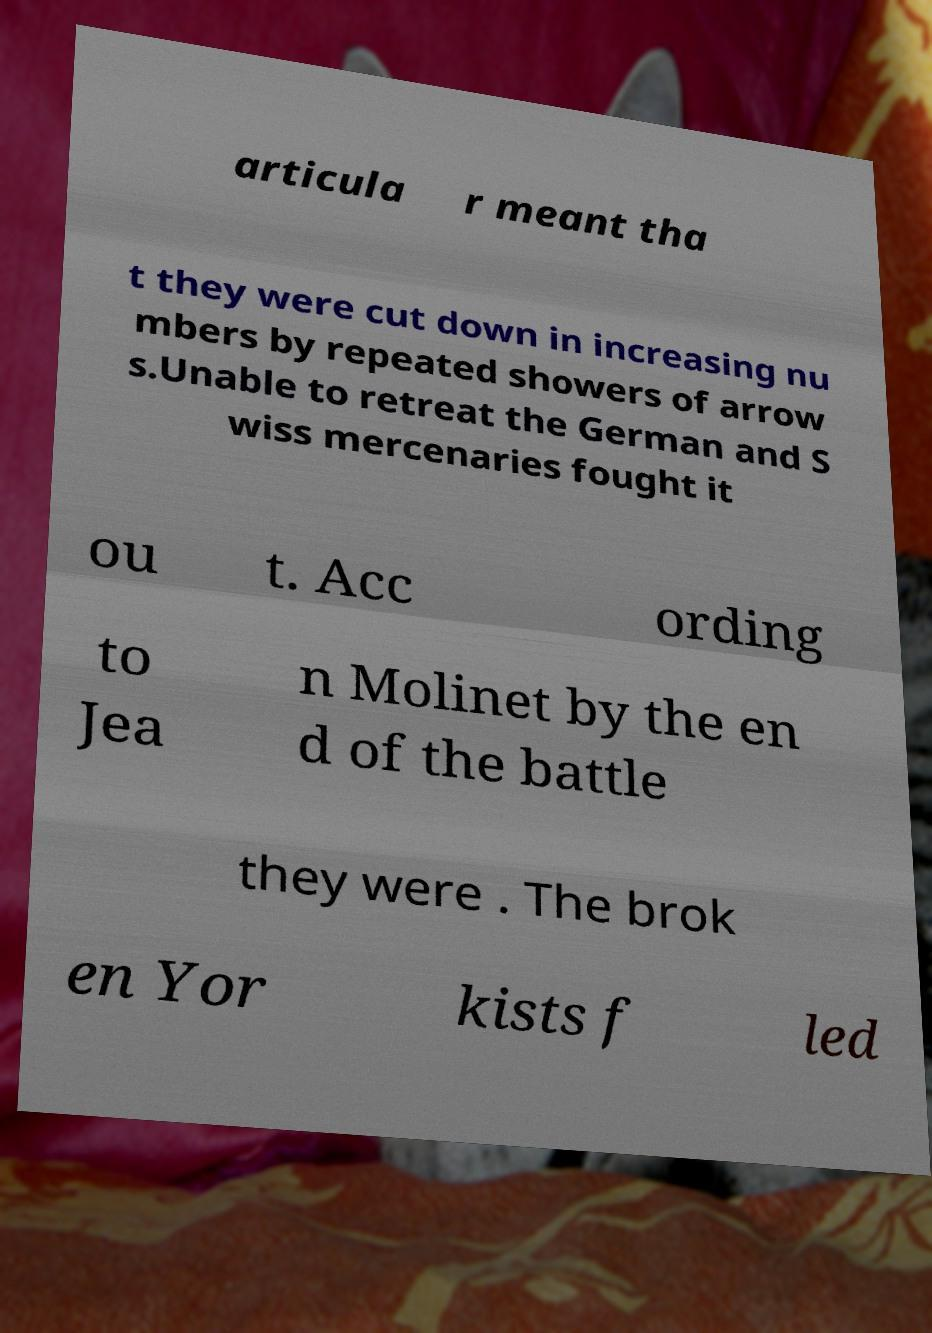For documentation purposes, I need the text within this image transcribed. Could you provide that? articula r meant tha t they were cut down in increasing nu mbers by repeated showers of arrow s.Unable to retreat the German and S wiss mercenaries fought it ou t. Acc ording to Jea n Molinet by the en d of the battle they were . The brok en Yor kists f led 